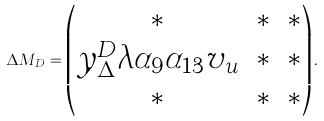Convert formula to latex. <formula><loc_0><loc_0><loc_500><loc_500>\Delta M _ { D } = \begin{pmatrix} \ast & \ast & \ast \\ y _ { \Delta } ^ { D } \lambda \alpha _ { 9 } \alpha _ { 1 3 } v _ { u } & \ast & \ast \\ \ast & \ast & \ast \end{pmatrix} .</formula> 